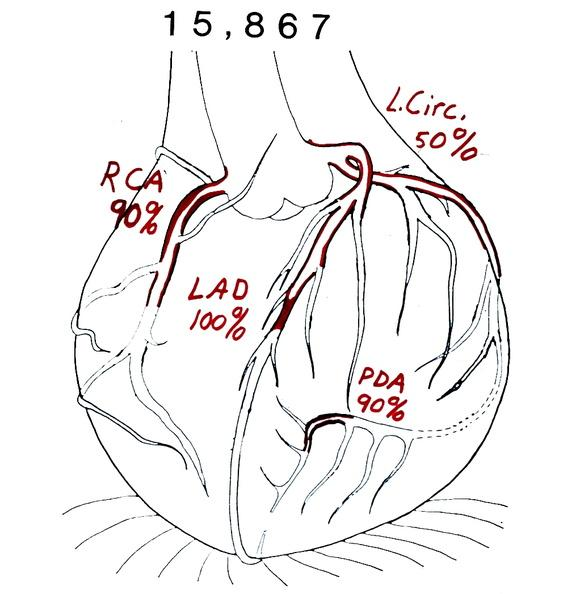does pus in test tube show coronary artery atherosclerosis diagram?
Answer the question using a single word or phrase. No 